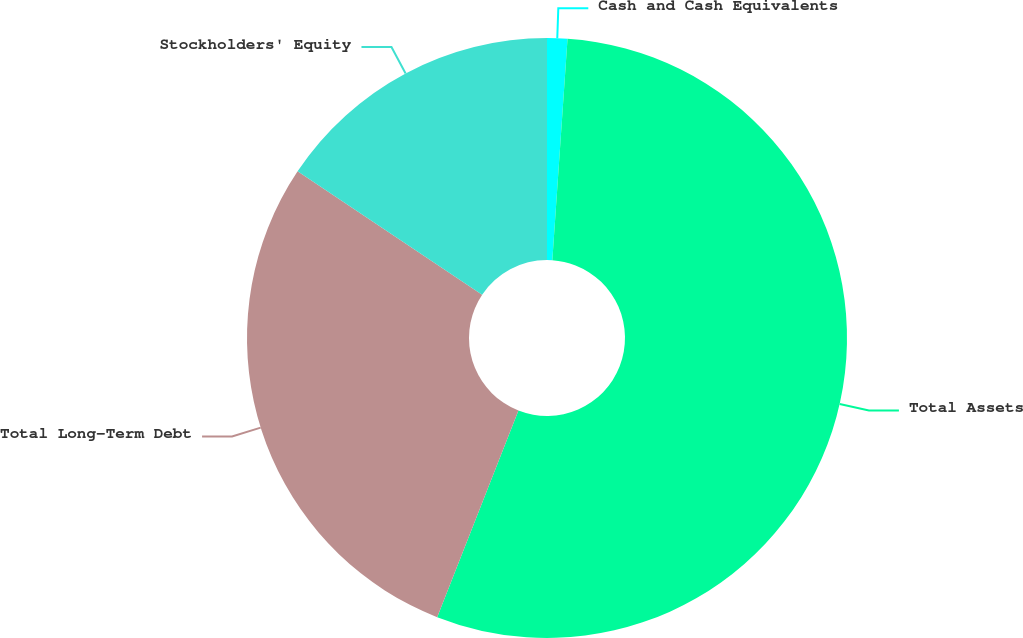Convert chart to OTSL. <chart><loc_0><loc_0><loc_500><loc_500><pie_chart><fcel>Cash and Cash Equivalents<fcel>Total Assets<fcel>Total Long-Term Debt<fcel>Stockholders' Equity<nl><fcel>1.09%<fcel>54.87%<fcel>28.41%<fcel>15.62%<nl></chart> 